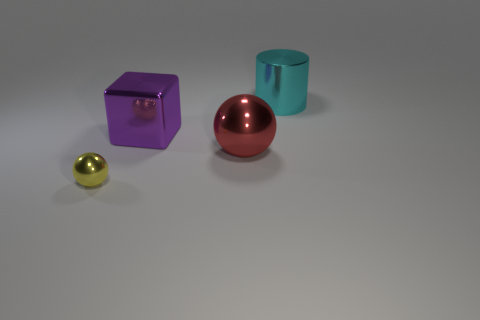Add 3 tiny blue matte balls. How many objects exist? 7 Subtract 0 blue blocks. How many objects are left? 4 Subtract all cylinders. How many objects are left? 3 Subtract 1 balls. How many balls are left? 1 Subtract all yellow spheres. Subtract all gray cubes. How many spheres are left? 1 Subtract all gray balls. How many gray cylinders are left? 0 Subtract all large red metal things. Subtract all small yellow balls. How many objects are left? 2 Add 1 large red metallic things. How many large red metallic things are left? 2 Add 3 tiny green shiny cylinders. How many tiny green shiny cylinders exist? 3 